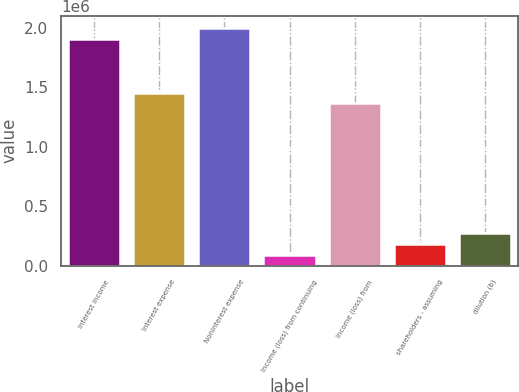<chart> <loc_0><loc_0><loc_500><loc_500><bar_chart><fcel>Interest income<fcel>Interest expense<fcel>Noninterest expense<fcel>Income (loss) from continuing<fcel>Income (loss) from<fcel>shareholders - assuming<fcel>dilution (b)<nl><fcel>1.90733e+06<fcel>1.4532e+06<fcel>1.99816e+06<fcel>90825.4<fcel>1.36238e+06<fcel>181651<fcel>272476<nl></chart> 